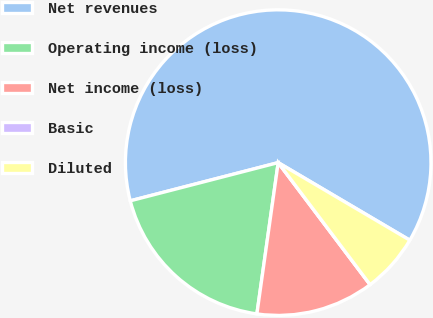Convert chart. <chart><loc_0><loc_0><loc_500><loc_500><pie_chart><fcel>Net revenues<fcel>Operating income (loss)<fcel>Net income (loss)<fcel>Basic<fcel>Diluted<nl><fcel>62.5%<fcel>18.75%<fcel>12.5%<fcel>0.0%<fcel>6.25%<nl></chart> 